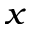<formula> <loc_0><loc_0><loc_500><loc_500>_ { x }</formula> 